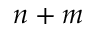Convert formula to latex. <formula><loc_0><loc_0><loc_500><loc_500>n + m</formula> 